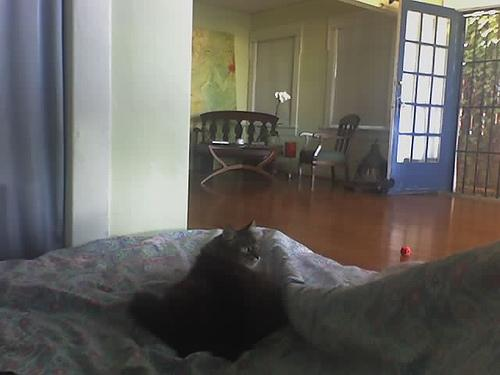The animal is resting on what? bed 